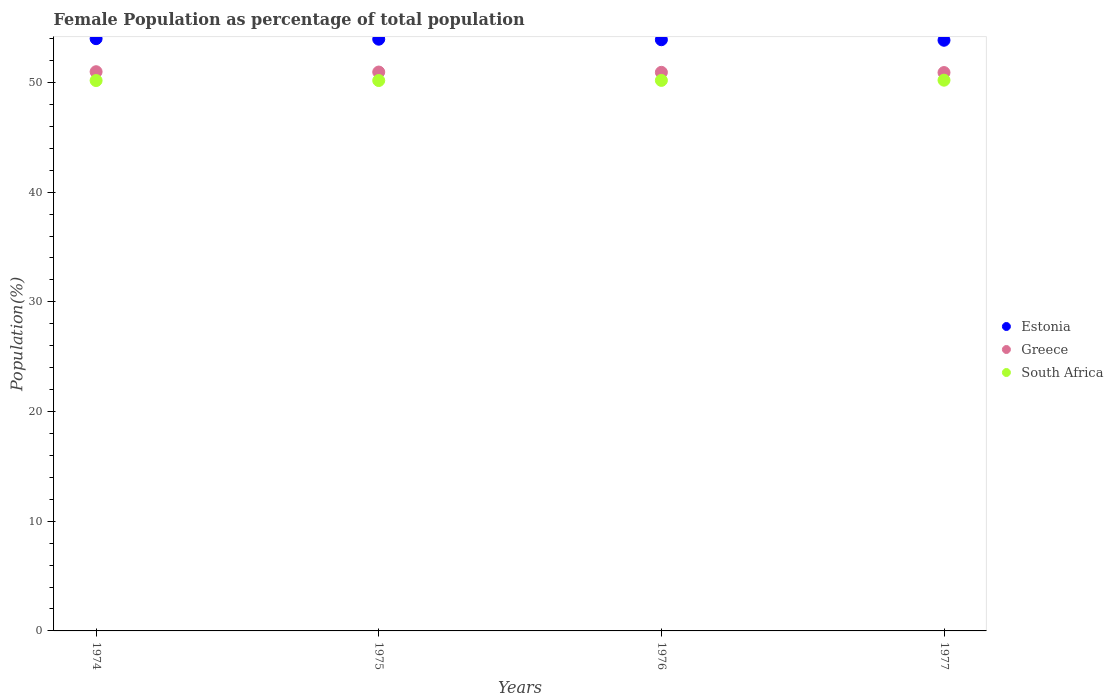Is the number of dotlines equal to the number of legend labels?
Provide a short and direct response. Yes. What is the female population in in Estonia in 1976?
Keep it short and to the point. 53.89. Across all years, what is the maximum female population in in Estonia?
Your answer should be very brief. 53.99. Across all years, what is the minimum female population in in South Africa?
Your answer should be very brief. 50.17. In which year was the female population in in Estonia maximum?
Provide a short and direct response. 1974. In which year was the female population in in South Africa minimum?
Offer a terse response. 1974. What is the total female population in in Greece in the graph?
Your response must be concise. 203.74. What is the difference between the female population in in South Africa in 1975 and that in 1977?
Offer a very short reply. -0.03. What is the difference between the female population in in Estonia in 1975 and the female population in in Greece in 1974?
Provide a short and direct response. 2.96. What is the average female population in in Estonia per year?
Keep it short and to the point. 53.92. In the year 1976, what is the difference between the female population in in Greece and female population in in Estonia?
Provide a short and direct response. -2.97. What is the ratio of the female population in in Estonia in 1974 to that in 1976?
Provide a succinct answer. 1. Is the difference between the female population in in Greece in 1976 and 1977 greater than the difference between the female population in in Estonia in 1976 and 1977?
Give a very brief answer. No. What is the difference between the highest and the second highest female population in in Greece?
Make the answer very short. 0.03. What is the difference between the highest and the lowest female population in in Greece?
Offer a terse response. 0.08. In how many years, is the female population in in Greece greater than the average female population in in Greece taken over all years?
Offer a very short reply. 2. Is it the case that in every year, the sum of the female population in in Estonia and female population in in South Africa  is greater than the female population in in Greece?
Give a very brief answer. Yes. Does the female population in in South Africa monotonically increase over the years?
Offer a terse response. Yes. Is the female population in in South Africa strictly greater than the female population in in Greece over the years?
Your answer should be compact. No. Is the female population in in Greece strictly less than the female population in in Estonia over the years?
Provide a short and direct response. Yes. How many dotlines are there?
Offer a terse response. 3. How many years are there in the graph?
Your answer should be very brief. 4. What is the title of the graph?
Your answer should be compact. Female Population as percentage of total population. Does "Albania" appear as one of the legend labels in the graph?
Provide a short and direct response. No. What is the label or title of the Y-axis?
Ensure brevity in your answer.  Population(%). What is the Population(%) in Estonia in 1974?
Your answer should be compact. 53.99. What is the Population(%) of Greece in 1974?
Your answer should be very brief. 50.98. What is the Population(%) in South Africa in 1974?
Your answer should be very brief. 50.17. What is the Population(%) of Estonia in 1975?
Give a very brief answer. 53.94. What is the Population(%) in Greece in 1975?
Make the answer very short. 50.95. What is the Population(%) in South Africa in 1975?
Your response must be concise. 50.17. What is the Population(%) of Estonia in 1976?
Give a very brief answer. 53.89. What is the Population(%) of Greece in 1976?
Keep it short and to the point. 50.92. What is the Population(%) of South Africa in 1976?
Your answer should be compact. 50.19. What is the Population(%) in Estonia in 1977?
Provide a succinct answer. 53.85. What is the Population(%) of Greece in 1977?
Keep it short and to the point. 50.9. What is the Population(%) of South Africa in 1977?
Your answer should be compact. 50.21. Across all years, what is the maximum Population(%) in Estonia?
Keep it short and to the point. 53.99. Across all years, what is the maximum Population(%) in Greece?
Provide a succinct answer. 50.98. Across all years, what is the maximum Population(%) of South Africa?
Offer a very short reply. 50.21. Across all years, what is the minimum Population(%) in Estonia?
Provide a short and direct response. 53.85. Across all years, what is the minimum Population(%) in Greece?
Provide a succinct answer. 50.9. Across all years, what is the minimum Population(%) of South Africa?
Ensure brevity in your answer.  50.17. What is the total Population(%) of Estonia in the graph?
Your answer should be very brief. 215.67. What is the total Population(%) of Greece in the graph?
Ensure brevity in your answer.  203.74. What is the total Population(%) of South Africa in the graph?
Ensure brevity in your answer.  200.74. What is the difference between the Population(%) of Estonia in 1974 and that in 1975?
Ensure brevity in your answer.  0.05. What is the difference between the Population(%) in Greece in 1974 and that in 1975?
Ensure brevity in your answer.  0.03. What is the difference between the Population(%) of South Africa in 1974 and that in 1975?
Ensure brevity in your answer.  -0. What is the difference between the Population(%) in Estonia in 1974 and that in 1976?
Provide a succinct answer. 0.1. What is the difference between the Population(%) in Greece in 1974 and that in 1976?
Your answer should be very brief. 0.06. What is the difference between the Population(%) of South Africa in 1974 and that in 1976?
Ensure brevity in your answer.  -0.01. What is the difference between the Population(%) of Estonia in 1974 and that in 1977?
Provide a short and direct response. 0.14. What is the difference between the Population(%) of Greece in 1974 and that in 1977?
Offer a very short reply. 0.08. What is the difference between the Population(%) in South Africa in 1974 and that in 1977?
Ensure brevity in your answer.  -0.03. What is the difference between the Population(%) in Estonia in 1975 and that in 1976?
Your response must be concise. 0.05. What is the difference between the Population(%) of Greece in 1975 and that in 1976?
Keep it short and to the point. 0.03. What is the difference between the Population(%) in South Africa in 1975 and that in 1976?
Offer a very short reply. -0.01. What is the difference between the Population(%) in Estonia in 1975 and that in 1977?
Provide a succinct answer. 0.1. What is the difference between the Population(%) in Greece in 1975 and that in 1977?
Provide a short and direct response. 0.05. What is the difference between the Population(%) in South Africa in 1975 and that in 1977?
Offer a very short reply. -0.03. What is the difference between the Population(%) in Estonia in 1976 and that in 1977?
Your answer should be compact. 0.05. What is the difference between the Population(%) of Greece in 1976 and that in 1977?
Ensure brevity in your answer.  0.02. What is the difference between the Population(%) in South Africa in 1976 and that in 1977?
Make the answer very short. -0.02. What is the difference between the Population(%) in Estonia in 1974 and the Population(%) in Greece in 1975?
Provide a succinct answer. 3.04. What is the difference between the Population(%) in Estonia in 1974 and the Population(%) in South Africa in 1975?
Provide a succinct answer. 3.81. What is the difference between the Population(%) in Greece in 1974 and the Population(%) in South Africa in 1975?
Your response must be concise. 0.8. What is the difference between the Population(%) of Estonia in 1974 and the Population(%) of Greece in 1976?
Give a very brief answer. 3.07. What is the difference between the Population(%) of Estonia in 1974 and the Population(%) of South Africa in 1976?
Offer a very short reply. 3.8. What is the difference between the Population(%) in Greece in 1974 and the Population(%) in South Africa in 1976?
Make the answer very short. 0.79. What is the difference between the Population(%) of Estonia in 1974 and the Population(%) of Greece in 1977?
Your answer should be very brief. 3.09. What is the difference between the Population(%) in Estonia in 1974 and the Population(%) in South Africa in 1977?
Your answer should be compact. 3.78. What is the difference between the Population(%) of Greece in 1974 and the Population(%) of South Africa in 1977?
Ensure brevity in your answer.  0.77. What is the difference between the Population(%) in Estonia in 1975 and the Population(%) in Greece in 1976?
Make the answer very short. 3.02. What is the difference between the Population(%) in Estonia in 1975 and the Population(%) in South Africa in 1976?
Offer a very short reply. 3.76. What is the difference between the Population(%) in Greece in 1975 and the Population(%) in South Africa in 1976?
Your answer should be very brief. 0.76. What is the difference between the Population(%) of Estonia in 1975 and the Population(%) of Greece in 1977?
Give a very brief answer. 3.04. What is the difference between the Population(%) of Estonia in 1975 and the Population(%) of South Africa in 1977?
Provide a short and direct response. 3.74. What is the difference between the Population(%) of Greece in 1975 and the Population(%) of South Africa in 1977?
Your answer should be compact. 0.74. What is the difference between the Population(%) in Estonia in 1976 and the Population(%) in Greece in 1977?
Make the answer very short. 2.99. What is the difference between the Population(%) in Estonia in 1976 and the Population(%) in South Africa in 1977?
Ensure brevity in your answer.  3.69. What is the difference between the Population(%) of Greece in 1976 and the Population(%) of South Africa in 1977?
Your answer should be very brief. 0.72. What is the average Population(%) of Estonia per year?
Offer a terse response. 53.92. What is the average Population(%) in Greece per year?
Give a very brief answer. 50.94. What is the average Population(%) of South Africa per year?
Provide a succinct answer. 50.18. In the year 1974, what is the difference between the Population(%) of Estonia and Population(%) of Greece?
Provide a succinct answer. 3.01. In the year 1974, what is the difference between the Population(%) of Estonia and Population(%) of South Africa?
Offer a terse response. 3.82. In the year 1974, what is the difference between the Population(%) of Greece and Population(%) of South Africa?
Keep it short and to the point. 0.8. In the year 1975, what is the difference between the Population(%) in Estonia and Population(%) in Greece?
Provide a short and direct response. 2.99. In the year 1975, what is the difference between the Population(%) in Estonia and Population(%) in South Africa?
Your response must be concise. 3.77. In the year 1975, what is the difference between the Population(%) of Greece and Population(%) of South Africa?
Your response must be concise. 0.77. In the year 1976, what is the difference between the Population(%) in Estonia and Population(%) in Greece?
Your answer should be very brief. 2.97. In the year 1976, what is the difference between the Population(%) in Estonia and Population(%) in South Africa?
Ensure brevity in your answer.  3.71. In the year 1976, what is the difference between the Population(%) in Greece and Population(%) in South Africa?
Your answer should be very brief. 0.73. In the year 1977, what is the difference between the Population(%) of Estonia and Population(%) of Greece?
Keep it short and to the point. 2.95. In the year 1977, what is the difference between the Population(%) in Estonia and Population(%) in South Africa?
Keep it short and to the point. 3.64. In the year 1977, what is the difference between the Population(%) of Greece and Population(%) of South Africa?
Provide a succinct answer. 0.69. What is the ratio of the Population(%) in Estonia in 1974 to that in 1975?
Offer a very short reply. 1. What is the ratio of the Population(%) of South Africa in 1974 to that in 1975?
Your answer should be compact. 1. What is the ratio of the Population(%) in Greece in 1974 to that in 1976?
Your answer should be very brief. 1. What is the ratio of the Population(%) in South Africa in 1974 to that in 1976?
Your answer should be compact. 1. What is the ratio of the Population(%) of South Africa in 1974 to that in 1977?
Offer a terse response. 1. What is the ratio of the Population(%) in Estonia in 1975 to that in 1976?
Your answer should be compact. 1. What is the ratio of the Population(%) of Greece in 1975 to that in 1976?
Your answer should be very brief. 1. What is the ratio of the Population(%) of Greece in 1975 to that in 1977?
Offer a very short reply. 1. What is the ratio of the Population(%) in South Africa in 1975 to that in 1977?
Your response must be concise. 1. What is the ratio of the Population(%) of South Africa in 1976 to that in 1977?
Give a very brief answer. 1. What is the difference between the highest and the second highest Population(%) in Estonia?
Your response must be concise. 0.05. What is the difference between the highest and the second highest Population(%) in Greece?
Give a very brief answer. 0.03. What is the difference between the highest and the second highest Population(%) in South Africa?
Offer a terse response. 0.02. What is the difference between the highest and the lowest Population(%) in Estonia?
Give a very brief answer. 0.14. What is the difference between the highest and the lowest Population(%) in Greece?
Offer a terse response. 0.08. What is the difference between the highest and the lowest Population(%) of South Africa?
Provide a succinct answer. 0.03. 